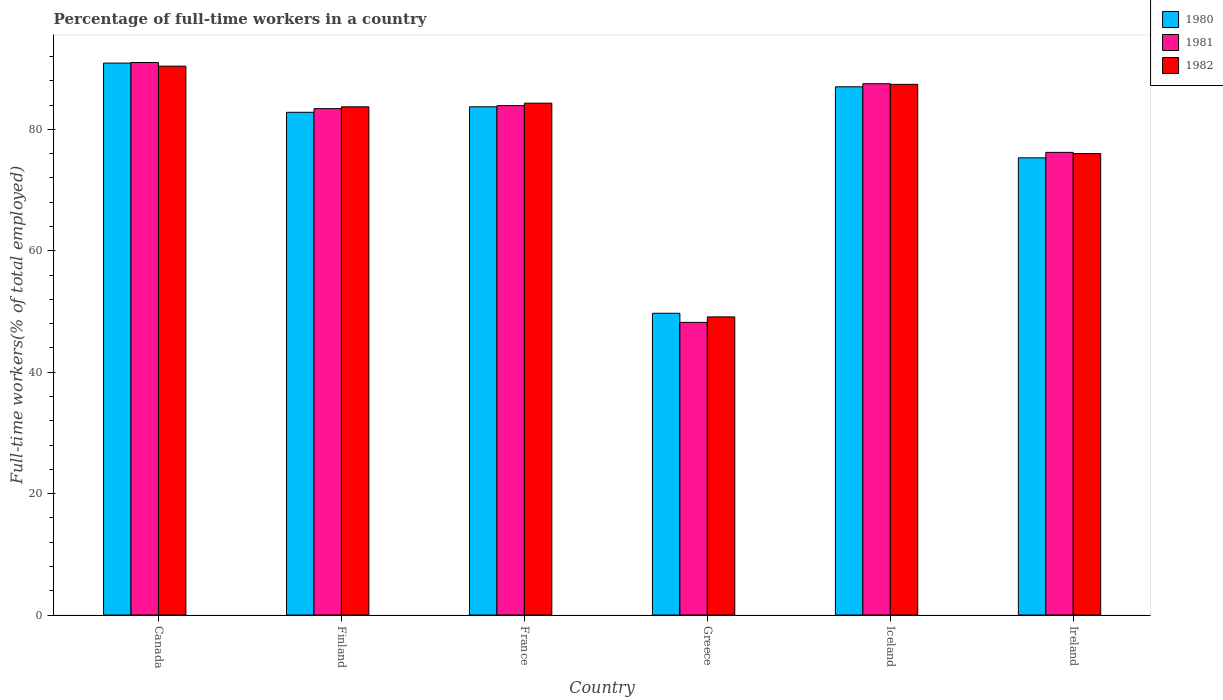How many different coloured bars are there?
Your response must be concise. 3. How many groups of bars are there?
Ensure brevity in your answer.  6. What is the label of the 5th group of bars from the left?
Your answer should be very brief. Iceland. In how many cases, is the number of bars for a given country not equal to the number of legend labels?
Ensure brevity in your answer.  0. What is the percentage of full-time workers in 1981 in France?
Your response must be concise. 83.9. Across all countries, what is the maximum percentage of full-time workers in 1980?
Provide a short and direct response. 90.9. Across all countries, what is the minimum percentage of full-time workers in 1981?
Your answer should be compact. 48.2. In which country was the percentage of full-time workers in 1982 maximum?
Your response must be concise. Canada. What is the total percentage of full-time workers in 1982 in the graph?
Your answer should be very brief. 470.9. What is the difference between the percentage of full-time workers in 1980 in France and that in Ireland?
Make the answer very short. 8.4. What is the difference between the percentage of full-time workers in 1981 in Finland and the percentage of full-time workers in 1980 in France?
Keep it short and to the point. -0.3. What is the average percentage of full-time workers in 1981 per country?
Keep it short and to the point. 78.37. What is the difference between the percentage of full-time workers of/in 1982 and percentage of full-time workers of/in 1981 in Greece?
Your response must be concise. 0.9. In how many countries, is the percentage of full-time workers in 1981 greater than 16 %?
Ensure brevity in your answer.  6. What is the ratio of the percentage of full-time workers in 1980 in Finland to that in Iceland?
Provide a succinct answer. 0.95. Is the difference between the percentage of full-time workers in 1982 in Canada and France greater than the difference between the percentage of full-time workers in 1981 in Canada and France?
Give a very brief answer. No. What is the difference between the highest and the second highest percentage of full-time workers in 1982?
Ensure brevity in your answer.  6.1. What is the difference between the highest and the lowest percentage of full-time workers in 1981?
Your answer should be compact. 42.8. What does the 3rd bar from the right in France represents?
Make the answer very short. 1980. How many bars are there?
Give a very brief answer. 18. How many countries are there in the graph?
Ensure brevity in your answer.  6. What is the difference between two consecutive major ticks on the Y-axis?
Your answer should be compact. 20. Does the graph contain grids?
Keep it short and to the point. No. Where does the legend appear in the graph?
Offer a very short reply. Top right. How many legend labels are there?
Your response must be concise. 3. How are the legend labels stacked?
Provide a short and direct response. Vertical. What is the title of the graph?
Your response must be concise. Percentage of full-time workers in a country. Does "1991" appear as one of the legend labels in the graph?
Make the answer very short. No. What is the label or title of the Y-axis?
Your response must be concise. Full-time workers(% of total employed). What is the Full-time workers(% of total employed) in 1980 in Canada?
Your answer should be very brief. 90.9. What is the Full-time workers(% of total employed) in 1981 in Canada?
Give a very brief answer. 91. What is the Full-time workers(% of total employed) in 1982 in Canada?
Your answer should be very brief. 90.4. What is the Full-time workers(% of total employed) of 1980 in Finland?
Your answer should be compact. 82.8. What is the Full-time workers(% of total employed) of 1981 in Finland?
Give a very brief answer. 83.4. What is the Full-time workers(% of total employed) of 1982 in Finland?
Provide a short and direct response. 83.7. What is the Full-time workers(% of total employed) of 1980 in France?
Offer a very short reply. 83.7. What is the Full-time workers(% of total employed) in 1981 in France?
Provide a succinct answer. 83.9. What is the Full-time workers(% of total employed) of 1982 in France?
Offer a very short reply. 84.3. What is the Full-time workers(% of total employed) of 1980 in Greece?
Offer a very short reply. 49.7. What is the Full-time workers(% of total employed) of 1981 in Greece?
Ensure brevity in your answer.  48.2. What is the Full-time workers(% of total employed) in 1982 in Greece?
Provide a succinct answer. 49.1. What is the Full-time workers(% of total employed) of 1981 in Iceland?
Your answer should be compact. 87.5. What is the Full-time workers(% of total employed) of 1982 in Iceland?
Provide a succinct answer. 87.4. What is the Full-time workers(% of total employed) in 1980 in Ireland?
Provide a succinct answer. 75.3. What is the Full-time workers(% of total employed) of 1981 in Ireland?
Offer a terse response. 76.2. What is the Full-time workers(% of total employed) in 1982 in Ireland?
Your response must be concise. 76. Across all countries, what is the maximum Full-time workers(% of total employed) of 1980?
Provide a succinct answer. 90.9. Across all countries, what is the maximum Full-time workers(% of total employed) in 1981?
Offer a very short reply. 91. Across all countries, what is the maximum Full-time workers(% of total employed) of 1982?
Ensure brevity in your answer.  90.4. Across all countries, what is the minimum Full-time workers(% of total employed) in 1980?
Your response must be concise. 49.7. Across all countries, what is the minimum Full-time workers(% of total employed) in 1981?
Provide a short and direct response. 48.2. Across all countries, what is the minimum Full-time workers(% of total employed) in 1982?
Offer a very short reply. 49.1. What is the total Full-time workers(% of total employed) of 1980 in the graph?
Offer a very short reply. 469.4. What is the total Full-time workers(% of total employed) of 1981 in the graph?
Provide a short and direct response. 470.2. What is the total Full-time workers(% of total employed) of 1982 in the graph?
Provide a succinct answer. 470.9. What is the difference between the Full-time workers(% of total employed) of 1981 in Canada and that in Finland?
Keep it short and to the point. 7.6. What is the difference between the Full-time workers(% of total employed) in 1982 in Canada and that in Finland?
Your answer should be compact. 6.7. What is the difference between the Full-time workers(% of total employed) of 1980 in Canada and that in France?
Make the answer very short. 7.2. What is the difference between the Full-time workers(% of total employed) of 1980 in Canada and that in Greece?
Provide a short and direct response. 41.2. What is the difference between the Full-time workers(% of total employed) in 1981 in Canada and that in Greece?
Give a very brief answer. 42.8. What is the difference between the Full-time workers(% of total employed) in 1982 in Canada and that in Greece?
Your response must be concise. 41.3. What is the difference between the Full-time workers(% of total employed) of 1980 in Canada and that in Iceland?
Keep it short and to the point. 3.9. What is the difference between the Full-time workers(% of total employed) in 1981 in Canada and that in Iceland?
Provide a succinct answer. 3.5. What is the difference between the Full-time workers(% of total employed) of 1982 in Canada and that in Iceland?
Keep it short and to the point. 3. What is the difference between the Full-time workers(% of total employed) in 1981 in Finland and that in France?
Provide a short and direct response. -0.5. What is the difference between the Full-time workers(% of total employed) of 1980 in Finland and that in Greece?
Make the answer very short. 33.1. What is the difference between the Full-time workers(% of total employed) in 1981 in Finland and that in Greece?
Give a very brief answer. 35.2. What is the difference between the Full-time workers(% of total employed) in 1982 in Finland and that in Greece?
Give a very brief answer. 34.6. What is the difference between the Full-time workers(% of total employed) of 1981 in Finland and that in Iceland?
Your answer should be very brief. -4.1. What is the difference between the Full-time workers(% of total employed) of 1980 in Finland and that in Ireland?
Offer a very short reply. 7.5. What is the difference between the Full-time workers(% of total employed) in 1980 in France and that in Greece?
Offer a terse response. 34. What is the difference between the Full-time workers(% of total employed) in 1981 in France and that in Greece?
Your response must be concise. 35.7. What is the difference between the Full-time workers(% of total employed) in 1982 in France and that in Greece?
Keep it short and to the point. 35.2. What is the difference between the Full-time workers(% of total employed) of 1980 in France and that in Iceland?
Your response must be concise. -3.3. What is the difference between the Full-time workers(% of total employed) of 1981 in France and that in Iceland?
Provide a short and direct response. -3.6. What is the difference between the Full-time workers(% of total employed) of 1982 in France and that in Iceland?
Your response must be concise. -3.1. What is the difference between the Full-time workers(% of total employed) of 1980 in France and that in Ireland?
Ensure brevity in your answer.  8.4. What is the difference between the Full-time workers(% of total employed) in 1982 in France and that in Ireland?
Keep it short and to the point. 8.3. What is the difference between the Full-time workers(% of total employed) of 1980 in Greece and that in Iceland?
Your answer should be compact. -37.3. What is the difference between the Full-time workers(% of total employed) of 1981 in Greece and that in Iceland?
Keep it short and to the point. -39.3. What is the difference between the Full-time workers(% of total employed) of 1982 in Greece and that in Iceland?
Your response must be concise. -38.3. What is the difference between the Full-time workers(% of total employed) of 1980 in Greece and that in Ireland?
Provide a succinct answer. -25.6. What is the difference between the Full-time workers(% of total employed) of 1982 in Greece and that in Ireland?
Provide a succinct answer. -26.9. What is the difference between the Full-time workers(% of total employed) of 1980 in Iceland and that in Ireland?
Ensure brevity in your answer.  11.7. What is the difference between the Full-time workers(% of total employed) of 1980 in Canada and the Full-time workers(% of total employed) of 1981 in Finland?
Your answer should be compact. 7.5. What is the difference between the Full-time workers(% of total employed) of 1980 in Canada and the Full-time workers(% of total employed) of 1982 in France?
Keep it short and to the point. 6.6. What is the difference between the Full-time workers(% of total employed) of 1980 in Canada and the Full-time workers(% of total employed) of 1981 in Greece?
Offer a terse response. 42.7. What is the difference between the Full-time workers(% of total employed) in 1980 in Canada and the Full-time workers(% of total employed) in 1982 in Greece?
Ensure brevity in your answer.  41.8. What is the difference between the Full-time workers(% of total employed) of 1981 in Canada and the Full-time workers(% of total employed) of 1982 in Greece?
Offer a very short reply. 41.9. What is the difference between the Full-time workers(% of total employed) of 1980 in Canada and the Full-time workers(% of total employed) of 1981 in Iceland?
Offer a terse response. 3.4. What is the difference between the Full-time workers(% of total employed) of 1980 in Canada and the Full-time workers(% of total employed) of 1981 in Ireland?
Your answer should be compact. 14.7. What is the difference between the Full-time workers(% of total employed) of 1980 in Finland and the Full-time workers(% of total employed) of 1981 in France?
Keep it short and to the point. -1.1. What is the difference between the Full-time workers(% of total employed) of 1980 in Finland and the Full-time workers(% of total employed) of 1981 in Greece?
Your answer should be very brief. 34.6. What is the difference between the Full-time workers(% of total employed) in 1980 in Finland and the Full-time workers(% of total employed) in 1982 in Greece?
Your answer should be very brief. 33.7. What is the difference between the Full-time workers(% of total employed) in 1981 in Finland and the Full-time workers(% of total employed) in 1982 in Greece?
Give a very brief answer. 34.3. What is the difference between the Full-time workers(% of total employed) in 1980 in Finland and the Full-time workers(% of total employed) in 1982 in Iceland?
Make the answer very short. -4.6. What is the difference between the Full-time workers(% of total employed) of 1981 in Finland and the Full-time workers(% of total employed) of 1982 in Iceland?
Your response must be concise. -4. What is the difference between the Full-time workers(% of total employed) in 1980 in Finland and the Full-time workers(% of total employed) in 1981 in Ireland?
Offer a terse response. 6.6. What is the difference between the Full-time workers(% of total employed) of 1980 in France and the Full-time workers(% of total employed) of 1981 in Greece?
Ensure brevity in your answer.  35.5. What is the difference between the Full-time workers(% of total employed) of 1980 in France and the Full-time workers(% of total employed) of 1982 in Greece?
Offer a very short reply. 34.6. What is the difference between the Full-time workers(% of total employed) in 1981 in France and the Full-time workers(% of total employed) in 1982 in Greece?
Your answer should be compact. 34.8. What is the difference between the Full-time workers(% of total employed) in 1980 in France and the Full-time workers(% of total employed) in 1981 in Iceland?
Provide a succinct answer. -3.8. What is the difference between the Full-time workers(% of total employed) of 1980 in France and the Full-time workers(% of total employed) of 1982 in Iceland?
Offer a very short reply. -3.7. What is the difference between the Full-time workers(% of total employed) in 1981 in France and the Full-time workers(% of total employed) in 1982 in Ireland?
Provide a succinct answer. 7.9. What is the difference between the Full-time workers(% of total employed) of 1980 in Greece and the Full-time workers(% of total employed) of 1981 in Iceland?
Offer a terse response. -37.8. What is the difference between the Full-time workers(% of total employed) of 1980 in Greece and the Full-time workers(% of total employed) of 1982 in Iceland?
Offer a very short reply. -37.7. What is the difference between the Full-time workers(% of total employed) of 1981 in Greece and the Full-time workers(% of total employed) of 1982 in Iceland?
Offer a very short reply. -39.2. What is the difference between the Full-time workers(% of total employed) of 1980 in Greece and the Full-time workers(% of total employed) of 1981 in Ireland?
Offer a terse response. -26.5. What is the difference between the Full-time workers(% of total employed) in 1980 in Greece and the Full-time workers(% of total employed) in 1982 in Ireland?
Offer a terse response. -26.3. What is the difference between the Full-time workers(% of total employed) of 1981 in Greece and the Full-time workers(% of total employed) of 1982 in Ireland?
Offer a terse response. -27.8. What is the difference between the Full-time workers(% of total employed) in 1980 in Iceland and the Full-time workers(% of total employed) in 1982 in Ireland?
Give a very brief answer. 11. What is the difference between the Full-time workers(% of total employed) of 1981 in Iceland and the Full-time workers(% of total employed) of 1982 in Ireland?
Your response must be concise. 11.5. What is the average Full-time workers(% of total employed) of 1980 per country?
Provide a succinct answer. 78.23. What is the average Full-time workers(% of total employed) in 1981 per country?
Keep it short and to the point. 78.37. What is the average Full-time workers(% of total employed) of 1982 per country?
Your response must be concise. 78.48. What is the difference between the Full-time workers(% of total employed) of 1980 and Full-time workers(% of total employed) of 1981 in Finland?
Keep it short and to the point. -0.6. What is the difference between the Full-time workers(% of total employed) of 1980 and Full-time workers(% of total employed) of 1982 in Finland?
Keep it short and to the point. -0.9. What is the difference between the Full-time workers(% of total employed) of 1981 and Full-time workers(% of total employed) of 1982 in Finland?
Provide a short and direct response. -0.3. What is the difference between the Full-time workers(% of total employed) of 1980 and Full-time workers(% of total employed) of 1982 in France?
Your answer should be very brief. -0.6. What is the difference between the Full-time workers(% of total employed) of 1981 and Full-time workers(% of total employed) of 1982 in France?
Provide a short and direct response. -0.4. What is the difference between the Full-time workers(% of total employed) in 1980 and Full-time workers(% of total employed) in 1981 in Greece?
Make the answer very short. 1.5. What is the difference between the Full-time workers(% of total employed) of 1980 and Full-time workers(% of total employed) of 1982 in Greece?
Your answer should be compact. 0.6. What is the difference between the Full-time workers(% of total employed) in 1980 and Full-time workers(% of total employed) in 1981 in Iceland?
Give a very brief answer. -0.5. What is the difference between the Full-time workers(% of total employed) in 1980 and Full-time workers(% of total employed) in 1982 in Iceland?
Give a very brief answer. -0.4. What is the ratio of the Full-time workers(% of total employed) in 1980 in Canada to that in Finland?
Keep it short and to the point. 1.1. What is the ratio of the Full-time workers(% of total employed) of 1981 in Canada to that in Finland?
Your answer should be very brief. 1.09. What is the ratio of the Full-time workers(% of total employed) in 1980 in Canada to that in France?
Provide a succinct answer. 1.09. What is the ratio of the Full-time workers(% of total employed) in 1981 in Canada to that in France?
Keep it short and to the point. 1.08. What is the ratio of the Full-time workers(% of total employed) of 1982 in Canada to that in France?
Keep it short and to the point. 1.07. What is the ratio of the Full-time workers(% of total employed) in 1980 in Canada to that in Greece?
Keep it short and to the point. 1.83. What is the ratio of the Full-time workers(% of total employed) in 1981 in Canada to that in Greece?
Provide a short and direct response. 1.89. What is the ratio of the Full-time workers(% of total employed) of 1982 in Canada to that in Greece?
Offer a very short reply. 1.84. What is the ratio of the Full-time workers(% of total employed) in 1980 in Canada to that in Iceland?
Keep it short and to the point. 1.04. What is the ratio of the Full-time workers(% of total employed) of 1981 in Canada to that in Iceland?
Your answer should be very brief. 1.04. What is the ratio of the Full-time workers(% of total employed) of 1982 in Canada to that in Iceland?
Ensure brevity in your answer.  1.03. What is the ratio of the Full-time workers(% of total employed) in 1980 in Canada to that in Ireland?
Offer a terse response. 1.21. What is the ratio of the Full-time workers(% of total employed) of 1981 in Canada to that in Ireland?
Provide a short and direct response. 1.19. What is the ratio of the Full-time workers(% of total employed) of 1982 in Canada to that in Ireland?
Make the answer very short. 1.19. What is the ratio of the Full-time workers(% of total employed) in 1980 in Finland to that in France?
Provide a short and direct response. 0.99. What is the ratio of the Full-time workers(% of total employed) in 1981 in Finland to that in France?
Offer a terse response. 0.99. What is the ratio of the Full-time workers(% of total employed) of 1980 in Finland to that in Greece?
Your response must be concise. 1.67. What is the ratio of the Full-time workers(% of total employed) of 1981 in Finland to that in Greece?
Offer a very short reply. 1.73. What is the ratio of the Full-time workers(% of total employed) in 1982 in Finland to that in Greece?
Make the answer very short. 1.7. What is the ratio of the Full-time workers(% of total employed) of 1980 in Finland to that in Iceland?
Ensure brevity in your answer.  0.95. What is the ratio of the Full-time workers(% of total employed) of 1981 in Finland to that in Iceland?
Your answer should be very brief. 0.95. What is the ratio of the Full-time workers(% of total employed) of 1982 in Finland to that in Iceland?
Provide a succinct answer. 0.96. What is the ratio of the Full-time workers(% of total employed) of 1980 in Finland to that in Ireland?
Provide a succinct answer. 1.1. What is the ratio of the Full-time workers(% of total employed) of 1981 in Finland to that in Ireland?
Make the answer very short. 1.09. What is the ratio of the Full-time workers(% of total employed) in 1982 in Finland to that in Ireland?
Offer a very short reply. 1.1. What is the ratio of the Full-time workers(% of total employed) in 1980 in France to that in Greece?
Offer a terse response. 1.68. What is the ratio of the Full-time workers(% of total employed) of 1981 in France to that in Greece?
Offer a terse response. 1.74. What is the ratio of the Full-time workers(% of total employed) in 1982 in France to that in Greece?
Your answer should be compact. 1.72. What is the ratio of the Full-time workers(% of total employed) in 1980 in France to that in Iceland?
Offer a terse response. 0.96. What is the ratio of the Full-time workers(% of total employed) of 1981 in France to that in Iceland?
Give a very brief answer. 0.96. What is the ratio of the Full-time workers(% of total employed) in 1982 in France to that in Iceland?
Make the answer very short. 0.96. What is the ratio of the Full-time workers(% of total employed) of 1980 in France to that in Ireland?
Your answer should be compact. 1.11. What is the ratio of the Full-time workers(% of total employed) in 1981 in France to that in Ireland?
Offer a terse response. 1.1. What is the ratio of the Full-time workers(% of total employed) of 1982 in France to that in Ireland?
Your response must be concise. 1.11. What is the ratio of the Full-time workers(% of total employed) of 1980 in Greece to that in Iceland?
Provide a short and direct response. 0.57. What is the ratio of the Full-time workers(% of total employed) of 1981 in Greece to that in Iceland?
Offer a terse response. 0.55. What is the ratio of the Full-time workers(% of total employed) in 1982 in Greece to that in Iceland?
Your answer should be compact. 0.56. What is the ratio of the Full-time workers(% of total employed) in 1980 in Greece to that in Ireland?
Your response must be concise. 0.66. What is the ratio of the Full-time workers(% of total employed) in 1981 in Greece to that in Ireland?
Provide a succinct answer. 0.63. What is the ratio of the Full-time workers(% of total employed) in 1982 in Greece to that in Ireland?
Make the answer very short. 0.65. What is the ratio of the Full-time workers(% of total employed) of 1980 in Iceland to that in Ireland?
Keep it short and to the point. 1.16. What is the ratio of the Full-time workers(% of total employed) of 1981 in Iceland to that in Ireland?
Make the answer very short. 1.15. What is the ratio of the Full-time workers(% of total employed) of 1982 in Iceland to that in Ireland?
Provide a succinct answer. 1.15. What is the difference between the highest and the second highest Full-time workers(% of total employed) of 1980?
Make the answer very short. 3.9. What is the difference between the highest and the second highest Full-time workers(% of total employed) of 1981?
Your response must be concise. 3.5. What is the difference between the highest and the lowest Full-time workers(% of total employed) in 1980?
Your response must be concise. 41.2. What is the difference between the highest and the lowest Full-time workers(% of total employed) of 1981?
Keep it short and to the point. 42.8. What is the difference between the highest and the lowest Full-time workers(% of total employed) of 1982?
Give a very brief answer. 41.3. 